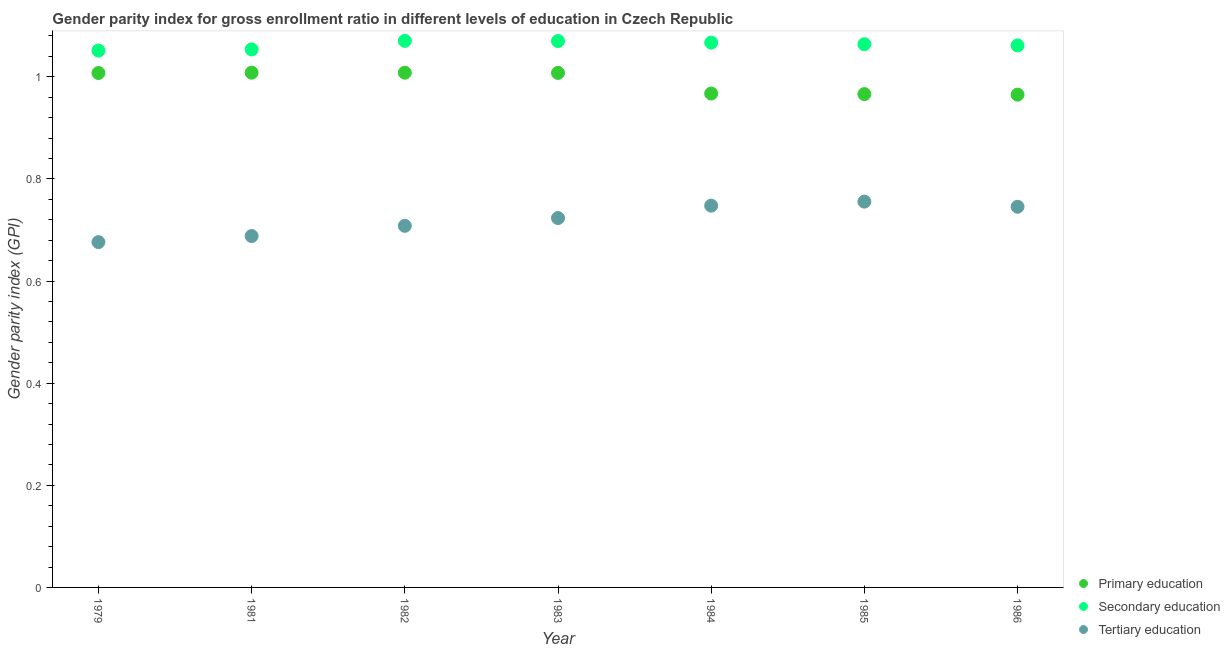What is the gender parity index in tertiary education in 1982?
Your answer should be compact. 0.71. Across all years, what is the maximum gender parity index in primary education?
Make the answer very short. 1.01. Across all years, what is the minimum gender parity index in tertiary education?
Make the answer very short. 0.68. What is the total gender parity index in secondary education in the graph?
Your answer should be compact. 7.44. What is the difference between the gender parity index in secondary education in 1983 and that in 1986?
Ensure brevity in your answer.  0.01. What is the difference between the gender parity index in tertiary education in 1981 and the gender parity index in primary education in 1986?
Provide a succinct answer. -0.28. What is the average gender parity index in primary education per year?
Give a very brief answer. 0.99. In the year 1986, what is the difference between the gender parity index in primary education and gender parity index in tertiary education?
Ensure brevity in your answer.  0.22. In how many years, is the gender parity index in primary education greater than 0.28?
Your answer should be very brief. 7. What is the ratio of the gender parity index in secondary education in 1983 to that in 1984?
Make the answer very short. 1. Is the gender parity index in secondary education in 1982 less than that in 1985?
Give a very brief answer. No. Is the difference between the gender parity index in tertiary education in 1983 and 1985 greater than the difference between the gender parity index in primary education in 1983 and 1985?
Provide a succinct answer. No. What is the difference between the highest and the second highest gender parity index in tertiary education?
Offer a very short reply. 0.01. What is the difference between the highest and the lowest gender parity index in primary education?
Keep it short and to the point. 0.04. Is the sum of the gender parity index in tertiary education in 1979 and 1986 greater than the maximum gender parity index in primary education across all years?
Keep it short and to the point. Yes. Is it the case that in every year, the sum of the gender parity index in primary education and gender parity index in secondary education is greater than the gender parity index in tertiary education?
Your answer should be very brief. Yes. Does the gender parity index in tertiary education monotonically increase over the years?
Ensure brevity in your answer.  No. Is the gender parity index in primary education strictly greater than the gender parity index in tertiary education over the years?
Offer a terse response. Yes. How many dotlines are there?
Give a very brief answer. 3. How many years are there in the graph?
Provide a succinct answer. 7. What is the difference between two consecutive major ticks on the Y-axis?
Ensure brevity in your answer.  0.2. Does the graph contain grids?
Provide a short and direct response. No. What is the title of the graph?
Your answer should be very brief. Gender parity index for gross enrollment ratio in different levels of education in Czech Republic. Does "Self-employed" appear as one of the legend labels in the graph?
Your response must be concise. No. What is the label or title of the X-axis?
Provide a short and direct response. Year. What is the label or title of the Y-axis?
Ensure brevity in your answer.  Gender parity index (GPI). What is the Gender parity index (GPI) in Primary education in 1979?
Give a very brief answer. 1.01. What is the Gender parity index (GPI) of Secondary education in 1979?
Your answer should be compact. 1.05. What is the Gender parity index (GPI) in Tertiary education in 1979?
Ensure brevity in your answer.  0.68. What is the Gender parity index (GPI) in Primary education in 1981?
Give a very brief answer. 1.01. What is the Gender parity index (GPI) in Secondary education in 1981?
Provide a short and direct response. 1.05. What is the Gender parity index (GPI) of Tertiary education in 1981?
Ensure brevity in your answer.  0.69. What is the Gender parity index (GPI) of Primary education in 1982?
Offer a terse response. 1.01. What is the Gender parity index (GPI) in Secondary education in 1982?
Make the answer very short. 1.07. What is the Gender parity index (GPI) of Tertiary education in 1982?
Offer a terse response. 0.71. What is the Gender parity index (GPI) of Primary education in 1983?
Offer a terse response. 1.01. What is the Gender parity index (GPI) in Secondary education in 1983?
Give a very brief answer. 1.07. What is the Gender parity index (GPI) of Tertiary education in 1983?
Offer a very short reply. 0.72. What is the Gender parity index (GPI) in Primary education in 1984?
Provide a succinct answer. 0.97. What is the Gender parity index (GPI) of Secondary education in 1984?
Provide a short and direct response. 1.07. What is the Gender parity index (GPI) of Tertiary education in 1984?
Your answer should be very brief. 0.75. What is the Gender parity index (GPI) in Primary education in 1985?
Your response must be concise. 0.97. What is the Gender parity index (GPI) in Secondary education in 1985?
Your answer should be compact. 1.06. What is the Gender parity index (GPI) in Tertiary education in 1985?
Your answer should be compact. 0.76. What is the Gender parity index (GPI) of Primary education in 1986?
Your answer should be compact. 0.97. What is the Gender parity index (GPI) of Secondary education in 1986?
Your answer should be very brief. 1.06. What is the Gender parity index (GPI) of Tertiary education in 1986?
Keep it short and to the point. 0.75. Across all years, what is the maximum Gender parity index (GPI) in Primary education?
Ensure brevity in your answer.  1.01. Across all years, what is the maximum Gender parity index (GPI) of Secondary education?
Offer a terse response. 1.07. Across all years, what is the maximum Gender parity index (GPI) of Tertiary education?
Make the answer very short. 0.76. Across all years, what is the minimum Gender parity index (GPI) of Primary education?
Keep it short and to the point. 0.97. Across all years, what is the minimum Gender parity index (GPI) in Secondary education?
Make the answer very short. 1.05. Across all years, what is the minimum Gender parity index (GPI) of Tertiary education?
Give a very brief answer. 0.68. What is the total Gender parity index (GPI) in Primary education in the graph?
Keep it short and to the point. 6.93. What is the total Gender parity index (GPI) of Secondary education in the graph?
Offer a terse response. 7.44. What is the total Gender parity index (GPI) in Tertiary education in the graph?
Keep it short and to the point. 5.04. What is the difference between the Gender parity index (GPI) in Primary education in 1979 and that in 1981?
Your answer should be compact. -0. What is the difference between the Gender parity index (GPI) of Secondary education in 1979 and that in 1981?
Ensure brevity in your answer.  -0. What is the difference between the Gender parity index (GPI) in Tertiary education in 1979 and that in 1981?
Offer a terse response. -0.01. What is the difference between the Gender parity index (GPI) in Primary education in 1979 and that in 1982?
Offer a very short reply. -0. What is the difference between the Gender parity index (GPI) in Secondary education in 1979 and that in 1982?
Make the answer very short. -0.02. What is the difference between the Gender parity index (GPI) in Tertiary education in 1979 and that in 1982?
Your answer should be very brief. -0.03. What is the difference between the Gender parity index (GPI) in Primary education in 1979 and that in 1983?
Offer a very short reply. -0. What is the difference between the Gender parity index (GPI) in Secondary education in 1979 and that in 1983?
Keep it short and to the point. -0.02. What is the difference between the Gender parity index (GPI) of Tertiary education in 1979 and that in 1983?
Provide a succinct answer. -0.05. What is the difference between the Gender parity index (GPI) in Primary education in 1979 and that in 1984?
Ensure brevity in your answer.  0.04. What is the difference between the Gender parity index (GPI) in Secondary education in 1979 and that in 1984?
Keep it short and to the point. -0.02. What is the difference between the Gender parity index (GPI) in Tertiary education in 1979 and that in 1984?
Your answer should be compact. -0.07. What is the difference between the Gender parity index (GPI) in Primary education in 1979 and that in 1985?
Give a very brief answer. 0.04. What is the difference between the Gender parity index (GPI) of Secondary education in 1979 and that in 1985?
Give a very brief answer. -0.01. What is the difference between the Gender parity index (GPI) in Tertiary education in 1979 and that in 1985?
Make the answer very short. -0.08. What is the difference between the Gender parity index (GPI) in Primary education in 1979 and that in 1986?
Provide a succinct answer. 0.04. What is the difference between the Gender parity index (GPI) of Secondary education in 1979 and that in 1986?
Give a very brief answer. -0.01. What is the difference between the Gender parity index (GPI) of Tertiary education in 1979 and that in 1986?
Your answer should be compact. -0.07. What is the difference between the Gender parity index (GPI) in Primary education in 1981 and that in 1982?
Provide a short and direct response. 0. What is the difference between the Gender parity index (GPI) in Secondary education in 1981 and that in 1982?
Make the answer very short. -0.02. What is the difference between the Gender parity index (GPI) in Tertiary education in 1981 and that in 1982?
Offer a very short reply. -0.02. What is the difference between the Gender parity index (GPI) in Primary education in 1981 and that in 1983?
Give a very brief answer. 0. What is the difference between the Gender parity index (GPI) of Secondary education in 1981 and that in 1983?
Give a very brief answer. -0.02. What is the difference between the Gender parity index (GPI) in Tertiary education in 1981 and that in 1983?
Your answer should be compact. -0.04. What is the difference between the Gender parity index (GPI) of Primary education in 1981 and that in 1984?
Give a very brief answer. 0.04. What is the difference between the Gender parity index (GPI) of Secondary education in 1981 and that in 1984?
Your answer should be compact. -0.01. What is the difference between the Gender parity index (GPI) in Tertiary education in 1981 and that in 1984?
Give a very brief answer. -0.06. What is the difference between the Gender parity index (GPI) of Primary education in 1981 and that in 1985?
Your response must be concise. 0.04. What is the difference between the Gender parity index (GPI) of Secondary education in 1981 and that in 1985?
Make the answer very short. -0.01. What is the difference between the Gender parity index (GPI) of Tertiary education in 1981 and that in 1985?
Make the answer very short. -0.07. What is the difference between the Gender parity index (GPI) in Primary education in 1981 and that in 1986?
Make the answer very short. 0.04. What is the difference between the Gender parity index (GPI) in Secondary education in 1981 and that in 1986?
Your answer should be very brief. -0.01. What is the difference between the Gender parity index (GPI) of Tertiary education in 1981 and that in 1986?
Keep it short and to the point. -0.06. What is the difference between the Gender parity index (GPI) in Primary education in 1982 and that in 1983?
Your answer should be compact. 0. What is the difference between the Gender parity index (GPI) in Secondary education in 1982 and that in 1983?
Provide a short and direct response. 0. What is the difference between the Gender parity index (GPI) of Tertiary education in 1982 and that in 1983?
Make the answer very short. -0.02. What is the difference between the Gender parity index (GPI) in Primary education in 1982 and that in 1984?
Your answer should be very brief. 0.04. What is the difference between the Gender parity index (GPI) of Secondary education in 1982 and that in 1984?
Give a very brief answer. 0. What is the difference between the Gender parity index (GPI) in Tertiary education in 1982 and that in 1984?
Ensure brevity in your answer.  -0.04. What is the difference between the Gender parity index (GPI) of Primary education in 1982 and that in 1985?
Offer a terse response. 0.04. What is the difference between the Gender parity index (GPI) of Secondary education in 1982 and that in 1985?
Give a very brief answer. 0.01. What is the difference between the Gender parity index (GPI) in Tertiary education in 1982 and that in 1985?
Make the answer very short. -0.05. What is the difference between the Gender parity index (GPI) in Primary education in 1982 and that in 1986?
Your answer should be very brief. 0.04. What is the difference between the Gender parity index (GPI) in Secondary education in 1982 and that in 1986?
Your response must be concise. 0.01. What is the difference between the Gender parity index (GPI) of Tertiary education in 1982 and that in 1986?
Offer a very short reply. -0.04. What is the difference between the Gender parity index (GPI) in Primary education in 1983 and that in 1984?
Offer a very short reply. 0.04. What is the difference between the Gender parity index (GPI) of Secondary education in 1983 and that in 1984?
Provide a short and direct response. 0. What is the difference between the Gender parity index (GPI) in Tertiary education in 1983 and that in 1984?
Offer a very short reply. -0.02. What is the difference between the Gender parity index (GPI) in Primary education in 1983 and that in 1985?
Keep it short and to the point. 0.04. What is the difference between the Gender parity index (GPI) of Secondary education in 1983 and that in 1985?
Your answer should be very brief. 0.01. What is the difference between the Gender parity index (GPI) in Tertiary education in 1983 and that in 1985?
Provide a short and direct response. -0.03. What is the difference between the Gender parity index (GPI) in Primary education in 1983 and that in 1986?
Your response must be concise. 0.04. What is the difference between the Gender parity index (GPI) in Secondary education in 1983 and that in 1986?
Give a very brief answer. 0.01. What is the difference between the Gender parity index (GPI) of Tertiary education in 1983 and that in 1986?
Ensure brevity in your answer.  -0.02. What is the difference between the Gender parity index (GPI) in Primary education in 1984 and that in 1985?
Offer a very short reply. 0. What is the difference between the Gender parity index (GPI) in Secondary education in 1984 and that in 1985?
Keep it short and to the point. 0. What is the difference between the Gender parity index (GPI) in Tertiary education in 1984 and that in 1985?
Your response must be concise. -0.01. What is the difference between the Gender parity index (GPI) in Primary education in 1984 and that in 1986?
Give a very brief answer. 0. What is the difference between the Gender parity index (GPI) in Secondary education in 1984 and that in 1986?
Offer a very short reply. 0.01. What is the difference between the Gender parity index (GPI) in Tertiary education in 1984 and that in 1986?
Your answer should be very brief. 0. What is the difference between the Gender parity index (GPI) of Primary education in 1985 and that in 1986?
Make the answer very short. 0. What is the difference between the Gender parity index (GPI) in Secondary education in 1985 and that in 1986?
Your answer should be compact. 0. What is the difference between the Gender parity index (GPI) in Tertiary education in 1985 and that in 1986?
Make the answer very short. 0.01. What is the difference between the Gender parity index (GPI) in Primary education in 1979 and the Gender parity index (GPI) in Secondary education in 1981?
Offer a very short reply. -0.05. What is the difference between the Gender parity index (GPI) in Primary education in 1979 and the Gender parity index (GPI) in Tertiary education in 1981?
Give a very brief answer. 0.32. What is the difference between the Gender parity index (GPI) of Secondary education in 1979 and the Gender parity index (GPI) of Tertiary education in 1981?
Offer a very short reply. 0.36. What is the difference between the Gender parity index (GPI) of Primary education in 1979 and the Gender parity index (GPI) of Secondary education in 1982?
Your response must be concise. -0.06. What is the difference between the Gender parity index (GPI) of Primary education in 1979 and the Gender parity index (GPI) of Tertiary education in 1982?
Your answer should be very brief. 0.3. What is the difference between the Gender parity index (GPI) of Secondary education in 1979 and the Gender parity index (GPI) of Tertiary education in 1982?
Provide a short and direct response. 0.34. What is the difference between the Gender parity index (GPI) in Primary education in 1979 and the Gender parity index (GPI) in Secondary education in 1983?
Keep it short and to the point. -0.06. What is the difference between the Gender parity index (GPI) of Primary education in 1979 and the Gender parity index (GPI) of Tertiary education in 1983?
Provide a short and direct response. 0.28. What is the difference between the Gender parity index (GPI) of Secondary education in 1979 and the Gender parity index (GPI) of Tertiary education in 1983?
Make the answer very short. 0.33. What is the difference between the Gender parity index (GPI) in Primary education in 1979 and the Gender parity index (GPI) in Secondary education in 1984?
Keep it short and to the point. -0.06. What is the difference between the Gender parity index (GPI) of Primary education in 1979 and the Gender parity index (GPI) of Tertiary education in 1984?
Offer a very short reply. 0.26. What is the difference between the Gender parity index (GPI) in Secondary education in 1979 and the Gender parity index (GPI) in Tertiary education in 1984?
Offer a very short reply. 0.3. What is the difference between the Gender parity index (GPI) in Primary education in 1979 and the Gender parity index (GPI) in Secondary education in 1985?
Your response must be concise. -0.06. What is the difference between the Gender parity index (GPI) of Primary education in 1979 and the Gender parity index (GPI) of Tertiary education in 1985?
Make the answer very short. 0.25. What is the difference between the Gender parity index (GPI) in Secondary education in 1979 and the Gender parity index (GPI) in Tertiary education in 1985?
Your answer should be very brief. 0.3. What is the difference between the Gender parity index (GPI) of Primary education in 1979 and the Gender parity index (GPI) of Secondary education in 1986?
Ensure brevity in your answer.  -0.05. What is the difference between the Gender parity index (GPI) of Primary education in 1979 and the Gender parity index (GPI) of Tertiary education in 1986?
Give a very brief answer. 0.26. What is the difference between the Gender parity index (GPI) of Secondary education in 1979 and the Gender parity index (GPI) of Tertiary education in 1986?
Offer a very short reply. 0.31. What is the difference between the Gender parity index (GPI) in Primary education in 1981 and the Gender parity index (GPI) in Secondary education in 1982?
Make the answer very short. -0.06. What is the difference between the Gender parity index (GPI) of Primary education in 1981 and the Gender parity index (GPI) of Tertiary education in 1982?
Provide a succinct answer. 0.3. What is the difference between the Gender parity index (GPI) in Secondary education in 1981 and the Gender parity index (GPI) in Tertiary education in 1982?
Keep it short and to the point. 0.35. What is the difference between the Gender parity index (GPI) in Primary education in 1981 and the Gender parity index (GPI) in Secondary education in 1983?
Ensure brevity in your answer.  -0.06. What is the difference between the Gender parity index (GPI) of Primary education in 1981 and the Gender parity index (GPI) of Tertiary education in 1983?
Offer a terse response. 0.28. What is the difference between the Gender parity index (GPI) in Secondary education in 1981 and the Gender parity index (GPI) in Tertiary education in 1983?
Provide a short and direct response. 0.33. What is the difference between the Gender parity index (GPI) in Primary education in 1981 and the Gender parity index (GPI) in Secondary education in 1984?
Your response must be concise. -0.06. What is the difference between the Gender parity index (GPI) of Primary education in 1981 and the Gender parity index (GPI) of Tertiary education in 1984?
Provide a short and direct response. 0.26. What is the difference between the Gender parity index (GPI) of Secondary education in 1981 and the Gender parity index (GPI) of Tertiary education in 1984?
Ensure brevity in your answer.  0.31. What is the difference between the Gender parity index (GPI) in Primary education in 1981 and the Gender parity index (GPI) in Secondary education in 1985?
Provide a short and direct response. -0.06. What is the difference between the Gender parity index (GPI) in Primary education in 1981 and the Gender parity index (GPI) in Tertiary education in 1985?
Provide a short and direct response. 0.25. What is the difference between the Gender parity index (GPI) in Secondary education in 1981 and the Gender parity index (GPI) in Tertiary education in 1985?
Make the answer very short. 0.3. What is the difference between the Gender parity index (GPI) in Primary education in 1981 and the Gender parity index (GPI) in Secondary education in 1986?
Offer a terse response. -0.05. What is the difference between the Gender parity index (GPI) of Primary education in 1981 and the Gender parity index (GPI) of Tertiary education in 1986?
Your answer should be compact. 0.26. What is the difference between the Gender parity index (GPI) of Secondary education in 1981 and the Gender parity index (GPI) of Tertiary education in 1986?
Provide a succinct answer. 0.31. What is the difference between the Gender parity index (GPI) in Primary education in 1982 and the Gender parity index (GPI) in Secondary education in 1983?
Your answer should be compact. -0.06. What is the difference between the Gender parity index (GPI) of Primary education in 1982 and the Gender parity index (GPI) of Tertiary education in 1983?
Your answer should be compact. 0.28. What is the difference between the Gender parity index (GPI) in Secondary education in 1982 and the Gender parity index (GPI) in Tertiary education in 1983?
Keep it short and to the point. 0.35. What is the difference between the Gender parity index (GPI) of Primary education in 1982 and the Gender parity index (GPI) of Secondary education in 1984?
Keep it short and to the point. -0.06. What is the difference between the Gender parity index (GPI) of Primary education in 1982 and the Gender parity index (GPI) of Tertiary education in 1984?
Provide a succinct answer. 0.26. What is the difference between the Gender parity index (GPI) of Secondary education in 1982 and the Gender parity index (GPI) of Tertiary education in 1984?
Provide a succinct answer. 0.32. What is the difference between the Gender parity index (GPI) in Primary education in 1982 and the Gender parity index (GPI) in Secondary education in 1985?
Offer a very short reply. -0.06. What is the difference between the Gender parity index (GPI) of Primary education in 1982 and the Gender parity index (GPI) of Tertiary education in 1985?
Make the answer very short. 0.25. What is the difference between the Gender parity index (GPI) in Secondary education in 1982 and the Gender parity index (GPI) in Tertiary education in 1985?
Provide a short and direct response. 0.31. What is the difference between the Gender parity index (GPI) in Primary education in 1982 and the Gender parity index (GPI) in Secondary education in 1986?
Provide a short and direct response. -0.05. What is the difference between the Gender parity index (GPI) of Primary education in 1982 and the Gender parity index (GPI) of Tertiary education in 1986?
Provide a succinct answer. 0.26. What is the difference between the Gender parity index (GPI) of Secondary education in 1982 and the Gender parity index (GPI) of Tertiary education in 1986?
Provide a succinct answer. 0.32. What is the difference between the Gender parity index (GPI) in Primary education in 1983 and the Gender parity index (GPI) in Secondary education in 1984?
Offer a terse response. -0.06. What is the difference between the Gender parity index (GPI) of Primary education in 1983 and the Gender parity index (GPI) of Tertiary education in 1984?
Give a very brief answer. 0.26. What is the difference between the Gender parity index (GPI) in Secondary education in 1983 and the Gender parity index (GPI) in Tertiary education in 1984?
Offer a terse response. 0.32. What is the difference between the Gender parity index (GPI) in Primary education in 1983 and the Gender parity index (GPI) in Secondary education in 1985?
Give a very brief answer. -0.06. What is the difference between the Gender parity index (GPI) in Primary education in 1983 and the Gender parity index (GPI) in Tertiary education in 1985?
Give a very brief answer. 0.25. What is the difference between the Gender parity index (GPI) in Secondary education in 1983 and the Gender parity index (GPI) in Tertiary education in 1985?
Offer a terse response. 0.31. What is the difference between the Gender parity index (GPI) in Primary education in 1983 and the Gender parity index (GPI) in Secondary education in 1986?
Offer a very short reply. -0.05. What is the difference between the Gender parity index (GPI) in Primary education in 1983 and the Gender parity index (GPI) in Tertiary education in 1986?
Ensure brevity in your answer.  0.26. What is the difference between the Gender parity index (GPI) of Secondary education in 1983 and the Gender parity index (GPI) of Tertiary education in 1986?
Make the answer very short. 0.32. What is the difference between the Gender parity index (GPI) of Primary education in 1984 and the Gender parity index (GPI) of Secondary education in 1985?
Your answer should be compact. -0.1. What is the difference between the Gender parity index (GPI) in Primary education in 1984 and the Gender parity index (GPI) in Tertiary education in 1985?
Ensure brevity in your answer.  0.21. What is the difference between the Gender parity index (GPI) in Secondary education in 1984 and the Gender parity index (GPI) in Tertiary education in 1985?
Provide a short and direct response. 0.31. What is the difference between the Gender parity index (GPI) in Primary education in 1984 and the Gender parity index (GPI) in Secondary education in 1986?
Make the answer very short. -0.09. What is the difference between the Gender parity index (GPI) in Primary education in 1984 and the Gender parity index (GPI) in Tertiary education in 1986?
Make the answer very short. 0.22. What is the difference between the Gender parity index (GPI) in Secondary education in 1984 and the Gender parity index (GPI) in Tertiary education in 1986?
Ensure brevity in your answer.  0.32. What is the difference between the Gender parity index (GPI) in Primary education in 1985 and the Gender parity index (GPI) in Secondary education in 1986?
Offer a very short reply. -0.1. What is the difference between the Gender parity index (GPI) of Primary education in 1985 and the Gender parity index (GPI) of Tertiary education in 1986?
Offer a very short reply. 0.22. What is the difference between the Gender parity index (GPI) in Secondary education in 1985 and the Gender parity index (GPI) in Tertiary education in 1986?
Offer a terse response. 0.32. What is the average Gender parity index (GPI) in Secondary education per year?
Keep it short and to the point. 1.06. What is the average Gender parity index (GPI) in Tertiary education per year?
Ensure brevity in your answer.  0.72. In the year 1979, what is the difference between the Gender parity index (GPI) of Primary education and Gender parity index (GPI) of Secondary education?
Keep it short and to the point. -0.04. In the year 1979, what is the difference between the Gender parity index (GPI) in Primary education and Gender parity index (GPI) in Tertiary education?
Keep it short and to the point. 0.33. In the year 1979, what is the difference between the Gender parity index (GPI) of Secondary education and Gender parity index (GPI) of Tertiary education?
Provide a short and direct response. 0.38. In the year 1981, what is the difference between the Gender parity index (GPI) of Primary education and Gender parity index (GPI) of Secondary education?
Keep it short and to the point. -0.05. In the year 1981, what is the difference between the Gender parity index (GPI) of Primary education and Gender parity index (GPI) of Tertiary education?
Provide a succinct answer. 0.32. In the year 1981, what is the difference between the Gender parity index (GPI) in Secondary education and Gender parity index (GPI) in Tertiary education?
Your response must be concise. 0.37. In the year 1982, what is the difference between the Gender parity index (GPI) in Primary education and Gender parity index (GPI) in Secondary education?
Offer a very short reply. -0.06. In the year 1982, what is the difference between the Gender parity index (GPI) in Primary education and Gender parity index (GPI) in Tertiary education?
Make the answer very short. 0.3. In the year 1982, what is the difference between the Gender parity index (GPI) in Secondary education and Gender parity index (GPI) in Tertiary education?
Your response must be concise. 0.36. In the year 1983, what is the difference between the Gender parity index (GPI) of Primary education and Gender parity index (GPI) of Secondary education?
Your response must be concise. -0.06. In the year 1983, what is the difference between the Gender parity index (GPI) of Primary education and Gender parity index (GPI) of Tertiary education?
Offer a very short reply. 0.28. In the year 1983, what is the difference between the Gender parity index (GPI) in Secondary education and Gender parity index (GPI) in Tertiary education?
Your response must be concise. 0.35. In the year 1984, what is the difference between the Gender parity index (GPI) of Primary education and Gender parity index (GPI) of Secondary education?
Ensure brevity in your answer.  -0.1. In the year 1984, what is the difference between the Gender parity index (GPI) of Primary education and Gender parity index (GPI) of Tertiary education?
Provide a short and direct response. 0.22. In the year 1984, what is the difference between the Gender parity index (GPI) of Secondary education and Gender parity index (GPI) of Tertiary education?
Give a very brief answer. 0.32. In the year 1985, what is the difference between the Gender parity index (GPI) of Primary education and Gender parity index (GPI) of Secondary education?
Make the answer very short. -0.1. In the year 1985, what is the difference between the Gender parity index (GPI) of Primary education and Gender parity index (GPI) of Tertiary education?
Make the answer very short. 0.21. In the year 1985, what is the difference between the Gender parity index (GPI) in Secondary education and Gender parity index (GPI) in Tertiary education?
Your response must be concise. 0.31. In the year 1986, what is the difference between the Gender parity index (GPI) in Primary education and Gender parity index (GPI) in Secondary education?
Your answer should be very brief. -0.1. In the year 1986, what is the difference between the Gender parity index (GPI) in Primary education and Gender parity index (GPI) in Tertiary education?
Keep it short and to the point. 0.22. In the year 1986, what is the difference between the Gender parity index (GPI) of Secondary education and Gender parity index (GPI) of Tertiary education?
Provide a succinct answer. 0.32. What is the ratio of the Gender parity index (GPI) of Secondary education in 1979 to that in 1981?
Make the answer very short. 1. What is the ratio of the Gender parity index (GPI) in Tertiary education in 1979 to that in 1981?
Offer a very short reply. 0.98. What is the ratio of the Gender parity index (GPI) of Primary education in 1979 to that in 1982?
Offer a terse response. 1. What is the ratio of the Gender parity index (GPI) of Secondary education in 1979 to that in 1982?
Your answer should be compact. 0.98. What is the ratio of the Gender parity index (GPI) of Tertiary education in 1979 to that in 1982?
Provide a succinct answer. 0.95. What is the ratio of the Gender parity index (GPI) of Primary education in 1979 to that in 1983?
Your answer should be compact. 1. What is the ratio of the Gender parity index (GPI) of Secondary education in 1979 to that in 1983?
Your answer should be compact. 0.98. What is the ratio of the Gender parity index (GPI) of Tertiary education in 1979 to that in 1983?
Keep it short and to the point. 0.93. What is the ratio of the Gender parity index (GPI) in Primary education in 1979 to that in 1984?
Provide a succinct answer. 1.04. What is the ratio of the Gender parity index (GPI) in Secondary education in 1979 to that in 1984?
Offer a terse response. 0.99. What is the ratio of the Gender parity index (GPI) in Tertiary education in 1979 to that in 1984?
Keep it short and to the point. 0.9. What is the ratio of the Gender parity index (GPI) of Primary education in 1979 to that in 1985?
Your answer should be very brief. 1.04. What is the ratio of the Gender parity index (GPI) of Secondary education in 1979 to that in 1985?
Make the answer very short. 0.99. What is the ratio of the Gender parity index (GPI) in Tertiary education in 1979 to that in 1985?
Give a very brief answer. 0.9. What is the ratio of the Gender parity index (GPI) in Primary education in 1979 to that in 1986?
Provide a short and direct response. 1.04. What is the ratio of the Gender parity index (GPI) of Tertiary education in 1979 to that in 1986?
Ensure brevity in your answer.  0.91. What is the ratio of the Gender parity index (GPI) of Secondary education in 1981 to that in 1982?
Make the answer very short. 0.98. What is the ratio of the Gender parity index (GPI) in Tertiary education in 1981 to that in 1982?
Your answer should be compact. 0.97. What is the ratio of the Gender parity index (GPI) in Secondary education in 1981 to that in 1983?
Give a very brief answer. 0.98. What is the ratio of the Gender parity index (GPI) of Tertiary education in 1981 to that in 1983?
Give a very brief answer. 0.95. What is the ratio of the Gender parity index (GPI) of Primary education in 1981 to that in 1984?
Keep it short and to the point. 1.04. What is the ratio of the Gender parity index (GPI) in Secondary education in 1981 to that in 1984?
Give a very brief answer. 0.99. What is the ratio of the Gender parity index (GPI) of Tertiary education in 1981 to that in 1984?
Keep it short and to the point. 0.92. What is the ratio of the Gender parity index (GPI) of Primary education in 1981 to that in 1985?
Keep it short and to the point. 1.04. What is the ratio of the Gender parity index (GPI) of Secondary education in 1981 to that in 1985?
Keep it short and to the point. 0.99. What is the ratio of the Gender parity index (GPI) of Tertiary education in 1981 to that in 1985?
Provide a short and direct response. 0.91. What is the ratio of the Gender parity index (GPI) in Primary education in 1981 to that in 1986?
Provide a succinct answer. 1.04. What is the ratio of the Gender parity index (GPI) in Secondary education in 1981 to that in 1986?
Your answer should be compact. 0.99. What is the ratio of the Gender parity index (GPI) in Tertiary education in 1981 to that in 1986?
Make the answer very short. 0.92. What is the ratio of the Gender parity index (GPI) in Primary education in 1982 to that in 1983?
Ensure brevity in your answer.  1. What is the ratio of the Gender parity index (GPI) of Tertiary education in 1982 to that in 1983?
Ensure brevity in your answer.  0.98. What is the ratio of the Gender parity index (GPI) of Primary education in 1982 to that in 1984?
Keep it short and to the point. 1.04. What is the ratio of the Gender parity index (GPI) of Secondary education in 1982 to that in 1984?
Ensure brevity in your answer.  1. What is the ratio of the Gender parity index (GPI) of Tertiary education in 1982 to that in 1984?
Make the answer very short. 0.95. What is the ratio of the Gender parity index (GPI) of Primary education in 1982 to that in 1985?
Your response must be concise. 1.04. What is the ratio of the Gender parity index (GPI) in Tertiary education in 1982 to that in 1985?
Make the answer very short. 0.94. What is the ratio of the Gender parity index (GPI) in Primary education in 1982 to that in 1986?
Provide a succinct answer. 1.04. What is the ratio of the Gender parity index (GPI) in Secondary education in 1982 to that in 1986?
Offer a terse response. 1.01. What is the ratio of the Gender parity index (GPI) of Tertiary education in 1982 to that in 1986?
Make the answer very short. 0.95. What is the ratio of the Gender parity index (GPI) of Primary education in 1983 to that in 1984?
Your response must be concise. 1.04. What is the ratio of the Gender parity index (GPI) in Tertiary education in 1983 to that in 1984?
Your answer should be very brief. 0.97. What is the ratio of the Gender parity index (GPI) in Primary education in 1983 to that in 1985?
Your response must be concise. 1.04. What is the ratio of the Gender parity index (GPI) of Secondary education in 1983 to that in 1985?
Keep it short and to the point. 1.01. What is the ratio of the Gender parity index (GPI) of Tertiary education in 1983 to that in 1985?
Offer a very short reply. 0.96. What is the ratio of the Gender parity index (GPI) of Primary education in 1983 to that in 1986?
Provide a short and direct response. 1.04. What is the ratio of the Gender parity index (GPI) in Secondary education in 1983 to that in 1986?
Give a very brief answer. 1.01. What is the ratio of the Gender parity index (GPI) in Tertiary education in 1983 to that in 1986?
Provide a short and direct response. 0.97. What is the ratio of the Gender parity index (GPI) of Primary education in 1984 to that in 1985?
Make the answer very short. 1. What is the ratio of the Gender parity index (GPI) in Tertiary education in 1984 to that in 1985?
Offer a very short reply. 0.99. What is the ratio of the Gender parity index (GPI) in Secondary education in 1984 to that in 1986?
Keep it short and to the point. 1.01. What is the ratio of the Gender parity index (GPI) of Tertiary education in 1984 to that in 1986?
Your answer should be compact. 1. What is the ratio of the Gender parity index (GPI) of Primary education in 1985 to that in 1986?
Provide a succinct answer. 1. What is the ratio of the Gender parity index (GPI) of Secondary education in 1985 to that in 1986?
Ensure brevity in your answer.  1. What is the ratio of the Gender parity index (GPI) in Tertiary education in 1985 to that in 1986?
Offer a very short reply. 1.01. What is the difference between the highest and the second highest Gender parity index (GPI) of Tertiary education?
Provide a succinct answer. 0.01. What is the difference between the highest and the lowest Gender parity index (GPI) in Primary education?
Provide a short and direct response. 0.04. What is the difference between the highest and the lowest Gender parity index (GPI) in Secondary education?
Provide a succinct answer. 0.02. What is the difference between the highest and the lowest Gender parity index (GPI) of Tertiary education?
Give a very brief answer. 0.08. 